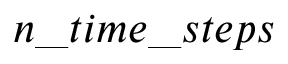<formula> <loc_0><loc_0><loc_500><loc_500>n \_ t i m e \_ s t e p s</formula> 